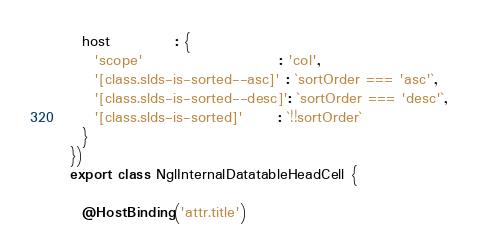Convert code to text. <code><loc_0><loc_0><loc_500><loc_500><_TypeScript_>  host           : {
    'scope'                       : 'col',
    '[class.slds-is-sorted--asc]' : `sortOrder === 'asc'`,
    '[class.slds-is-sorted--desc]': `sortOrder === 'desc'`,
    '[class.slds-is-sorted]'      : `!!sortOrder`
  }
})
export class NglInternalDatatableHeadCell {

  @HostBinding('attr.title')</code> 